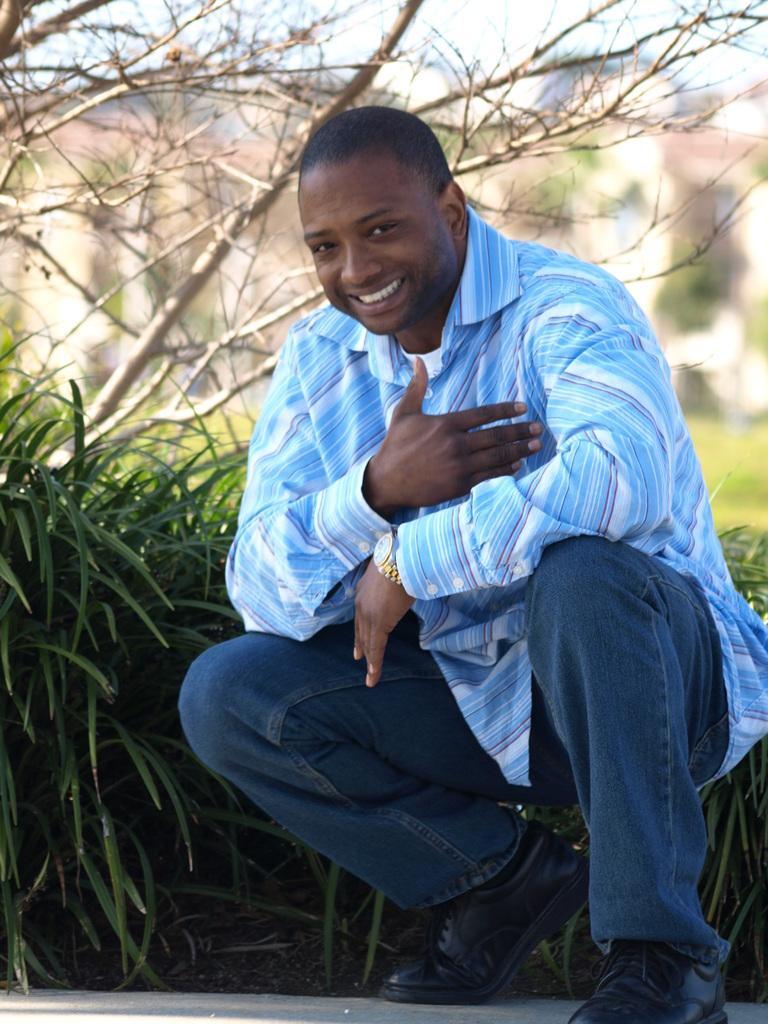Please provide a concise description of this image. In the center of the image we can see one person smiling, which we can see on his face. And we can see he is in blue and white color shirt. In the background, we can see the sky, clouds, one building, trees, grass, plants and a few other objects. 